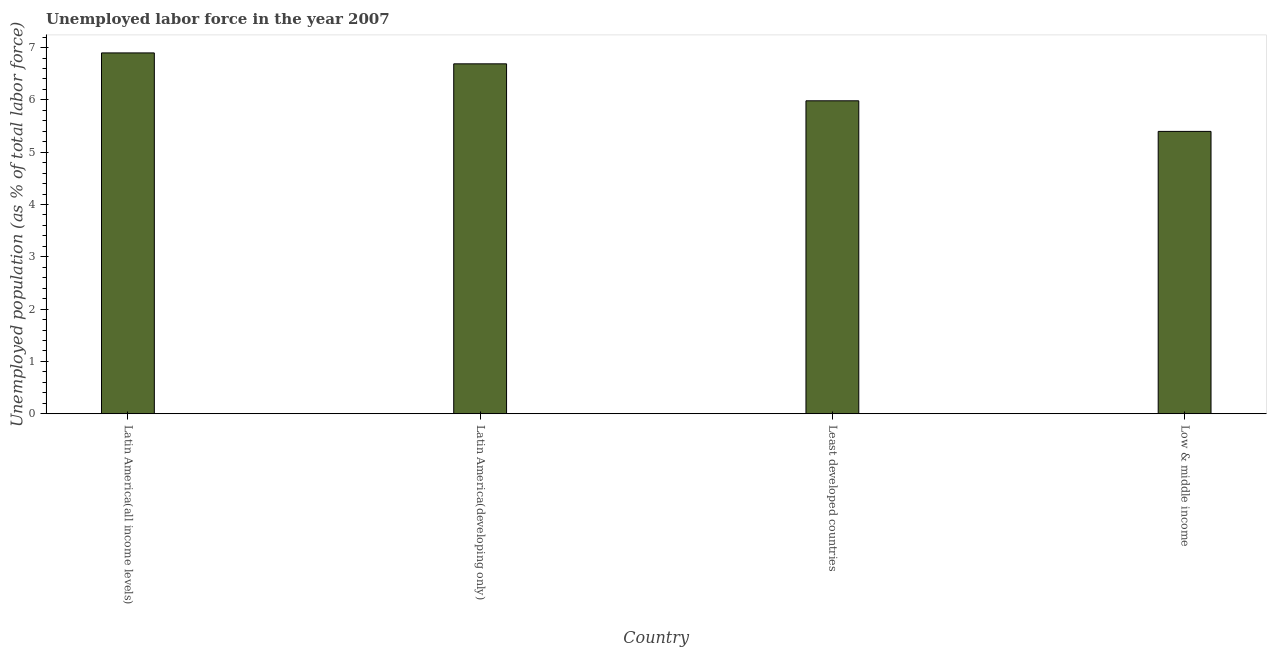Does the graph contain any zero values?
Give a very brief answer. No. What is the title of the graph?
Keep it short and to the point. Unemployed labor force in the year 2007. What is the label or title of the X-axis?
Offer a terse response. Country. What is the label or title of the Y-axis?
Your answer should be very brief. Unemployed population (as % of total labor force). What is the total unemployed population in Latin America(all income levels)?
Provide a succinct answer. 6.9. Across all countries, what is the maximum total unemployed population?
Ensure brevity in your answer.  6.9. Across all countries, what is the minimum total unemployed population?
Offer a terse response. 5.4. In which country was the total unemployed population maximum?
Ensure brevity in your answer.  Latin America(all income levels). What is the sum of the total unemployed population?
Offer a very short reply. 24.96. What is the difference between the total unemployed population in Latin America(all income levels) and Least developed countries?
Your answer should be very brief. 0.92. What is the average total unemployed population per country?
Your response must be concise. 6.24. What is the median total unemployed population?
Offer a very short reply. 6.34. What is the ratio of the total unemployed population in Latin America(developing only) to that in Low & middle income?
Your answer should be compact. 1.24. What is the difference between the highest and the second highest total unemployed population?
Provide a succinct answer. 0.21. What is the Unemployed population (as % of total labor force) of Latin America(all income levels)?
Offer a very short reply. 6.9. What is the Unemployed population (as % of total labor force) of Latin America(developing only)?
Ensure brevity in your answer.  6.69. What is the Unemployed population (as % of total labor force) of Least developed countries?
Provide a short and direct response. 5.98. What is the Unemployed population (as % of total labor force) in Low & middle income?
Provide a short and direct response. 5.4. What is the difference between the Unemployed population (as % of total labor force) in Latin America(all income levels) and Latin America(developing only)?
Offer a terse response. 0.21. What is the difference between the Unemployed population (as % of total labor force) in Latin America(all income levels) and Least developed countries?
Ensure brevity in your answer.  0.92. What is the difference between the Unemployed population (as % of total labor force) in Latin America(all income levels) and Low & middle income?
Your answer should be compact. 1.5. What is the difference between the Unemployed population (as % of total labor force) in Latin America(developing only) and Least developed countries?
Give a very brief answer. 0.71. What is the difference between the Unemployed population (as % of total labor force) in Latin America(developing only) and Low & middle income?
Offer a very short reply. 1.29. What is the difference between the Unemployed population (as % of total labor force) in Least developed countries and Low & middle income?
Offer a terse response. 0.58. What is the ratio of the Unemployed population (as % of total labor force) in Latin America(all income levels) to that in Latin America(developing only)?
Your answer should be compact. 1.03. What is the ratio of the Unemployed population (as % of total labor force) in Latin America(all income levels) to that in Least developed countries?
Give a very brief answer. 1.15. What is the ratio of the Unemployed population (as % of total labor force) in Latin America(all income levels) to that in Low & middle income?
Provide a succinct answer. 1.28. What is the ratio of the Unemployed population (as % of total labor force) in Latin America(developing only) to that in Least developed countries?
Your answer should be compact. 1.12. What is the ratio of the Unemployed population (as % of total labor force) in Latin America(developing only) to that in Low & middle income?
Give a very brief answer. 1.24. What is the ratio of the Unemployed population (as % of total labor force) in Least developed countries to that in Low & middle income?
Ensure brevity in your answer.  1.11. 